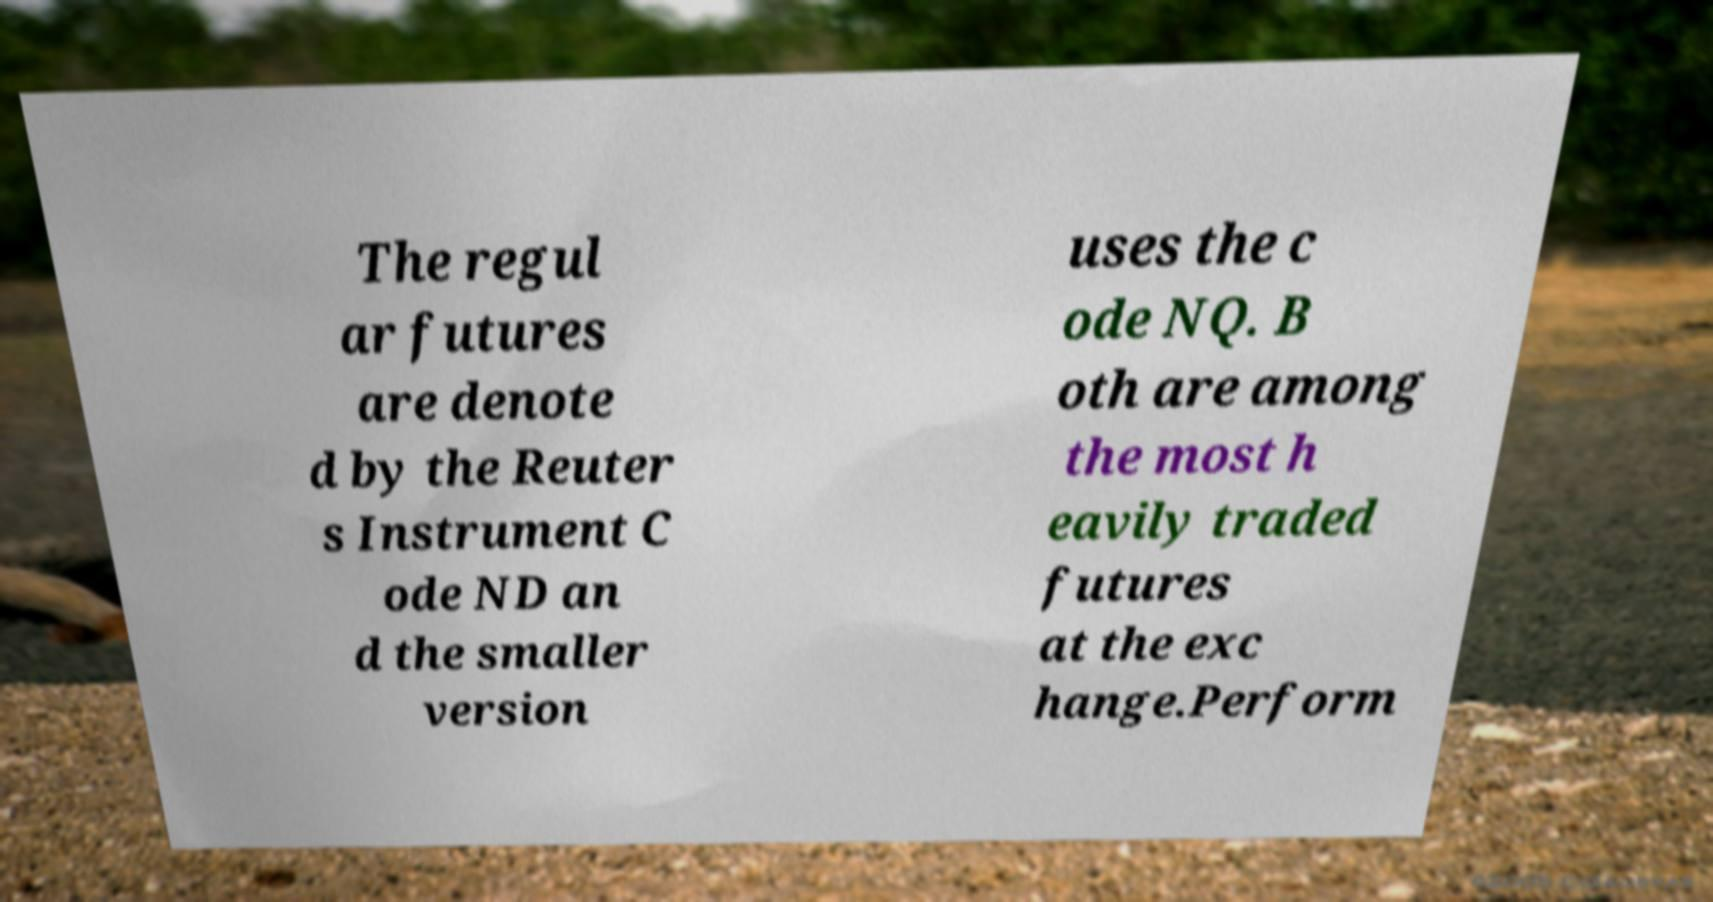For documentation purposes, I need the text within this image transcribed. Could you provide that? The regul ar futures are denote d by the Reuter s Instrument C ode ND an d the smaller version uses the c ode NQ. B oth are among the most h eavily traded futures at the exc hange.Perform 